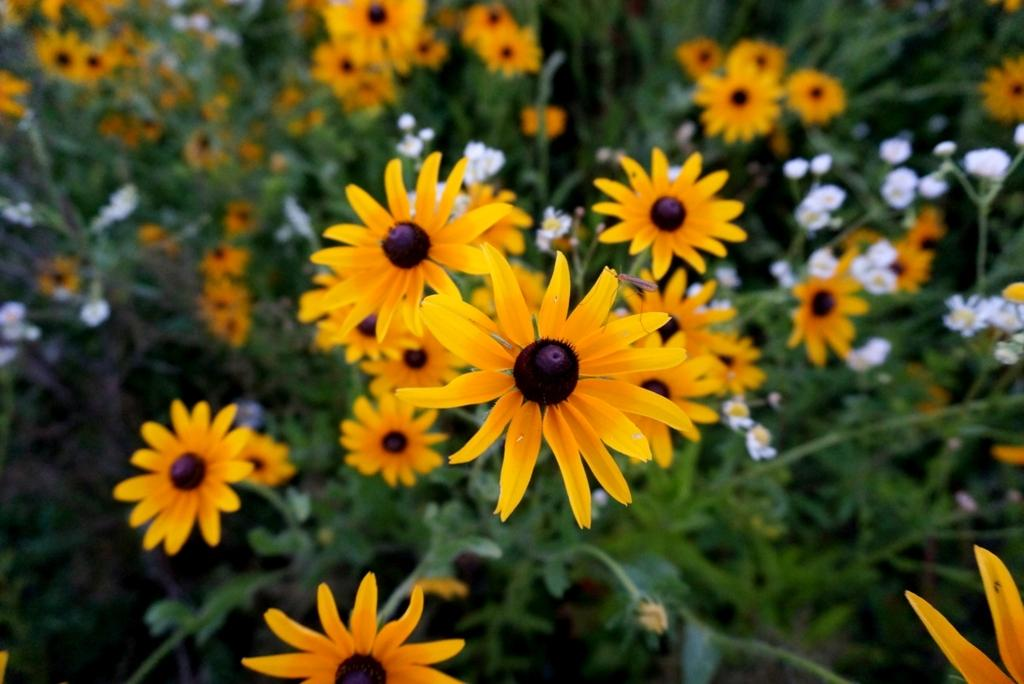What type of plants can be seen in the image? There are flower plants in the image. What scientific discoveries are being protested in the image? There is no protest or scientific discovery present in the image; it only features flower plants. 